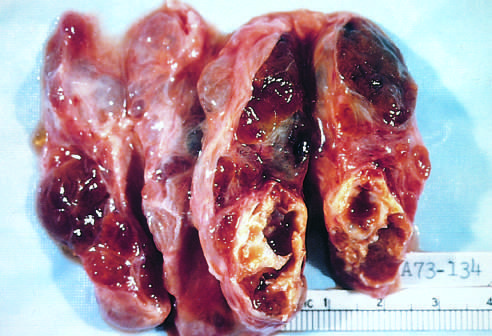does the injurious stimulus contain areas of fibrosis and cystic change?
Answer the question using a single word or phrase. No 